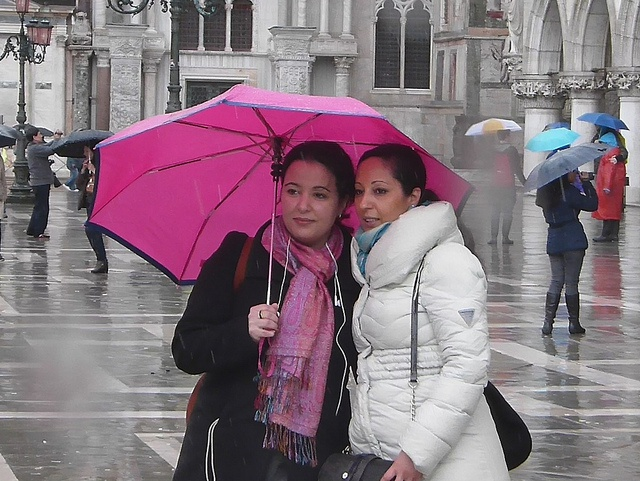Describe the objects in this image and their specific colors. I can see people in gray, black, brown, violet, and purple tones, people in gray, lightgray, darkgray, brown, and black tones, umbrella in gray, purple, and violet tones, people in gray and black tones, and people in gray, brown, black, and maroon tones in this image. 